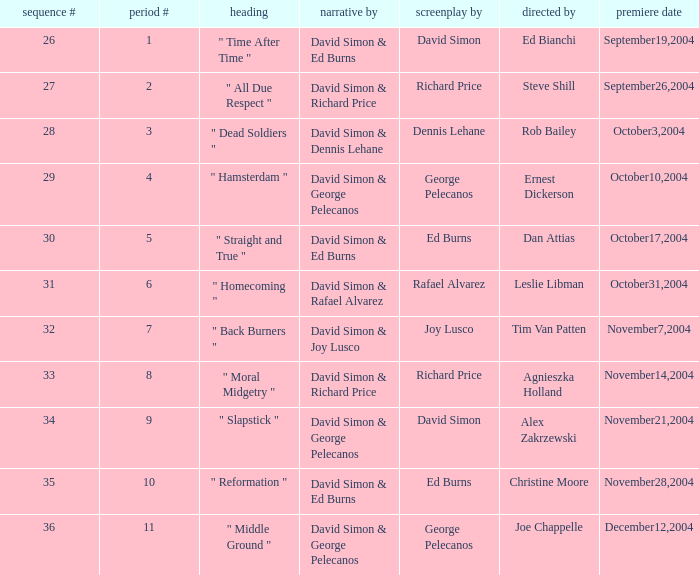What is the season # for a teleplay by Richard Price and the director is Steve Shill? 2.0. 